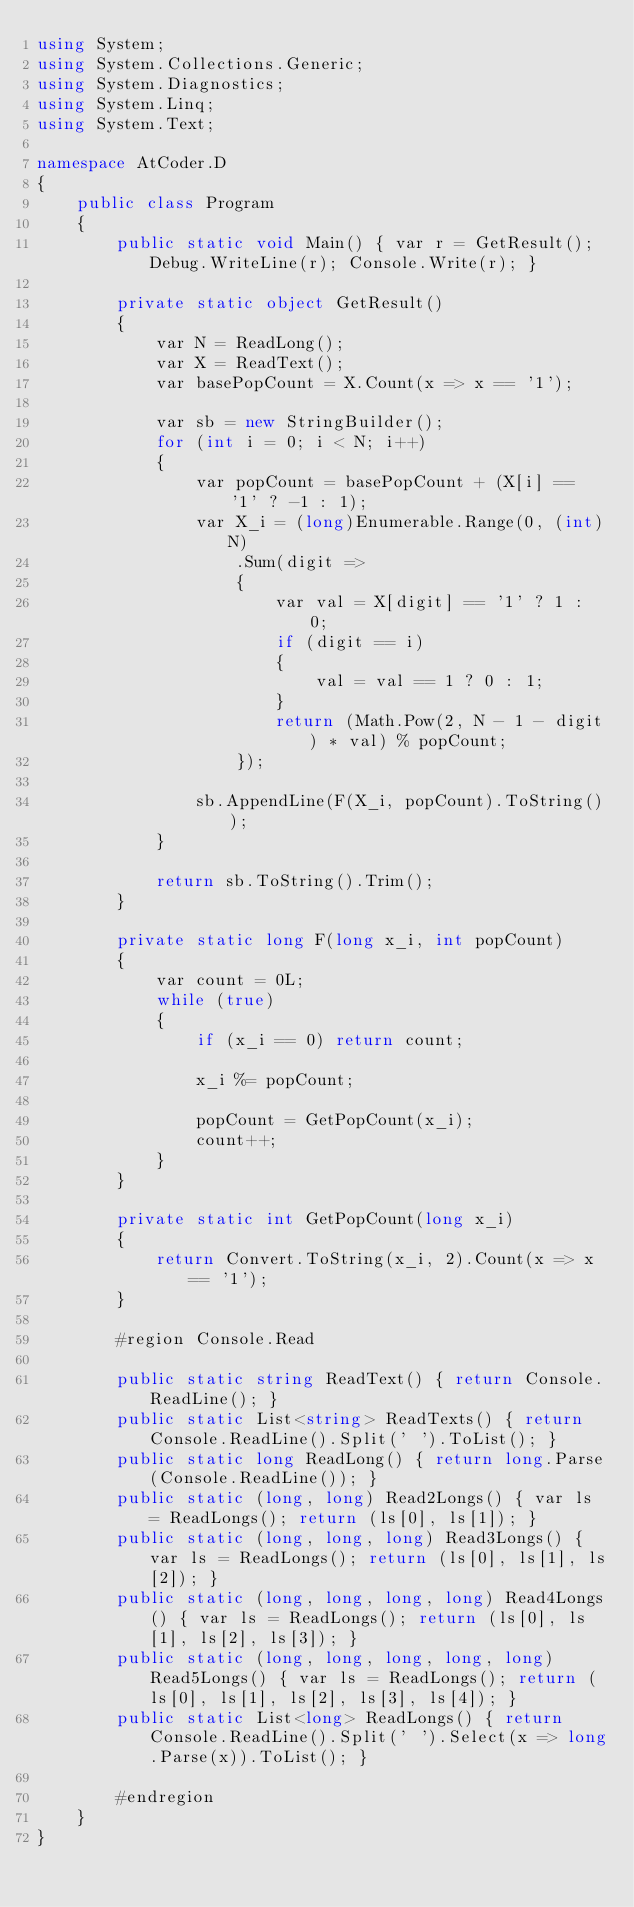<code> <loc_0><loc_0><loc_500><loc_500><_C#_>using System;
using System.Collections.Generic;
using System.Diagnostics;
using System.Linq;
using System.Text;

namespace AtCoder.D
{
    public class Program
    {
        public static void Main() { var r = GetResult(); Debug.WriteLine(r); Console.Write(r); }

        private static object GetResult()
        {
            var N = ReadLong();
            var X = ReadText();
            var basePopCount = X.Count(x => x == '1');

            var sb = new StringBuilder();
            for (int i = 0; i < N; i++)
            {
                var popCount = basePopCount + (X[i] == '1' ? -1 : 1);
                var X_i = (long)Enumerable.Range(0, (int)N)
                    .Sum(digit =>
                    {
                        var val = X[digit] == '1' ? 1 : 0;
                        if (digit == i)
                        {
                            val = val == 1 ? 0 : 1;
                        }
                        return (Math.Pow(2, N - 1 - digit) * val) % popCount;
                    });

                sb.AppendLine(F(X_i, popCount).ToString());
            }

            return sb.ToString().Trim();
        }

        private static long F(long x_i, int popCount)
        {
            var count = 0L;
            while (true)
            {
                if (x_i == 0) return count;

                x_i %= popCount;

                popCount = GetPopCount(x_i);
                count++;
            }
        }

        private static int GetPopCount(long x_i)
        {
            return Convert.ToString(x_i, 2).Count(x => x == '1');
        }

        #region Console.Read

        public static string ReadText() { return Console.ReadLine(); }
        public static List<string> ReadTexts() { return Console.ReadLine().Split(' ').ToList(); }
        public static long ReadLong() { return long.Parse(Console.ReadLine()); }
        public static (long, long) Read2Longs() { var ls = ReadLongs(); return (ls[0], ls[1]); }
        public static (long, long, long) Read3Longs() { var ls = ReadLongs(); return (ls[0], ls[1], ls[2]); }
        public static (long, long, long, long) Read4Longs() { var ls = ReadLongs(); return (ls[0], ls[1], ls[2], ls[3]); }
        public static (long, long, long, long, long) Read5Longs() { var ls = ReadLongs(); return (ls[0], ls[1], ls[2], ls[3], ls[4]); }
        public static List<long> ReadLongs() { return Console.ReadLine().Split(' ').Select(x => long.Parse(x)).ToList(); }

        #endregion
    }
}
</code> 